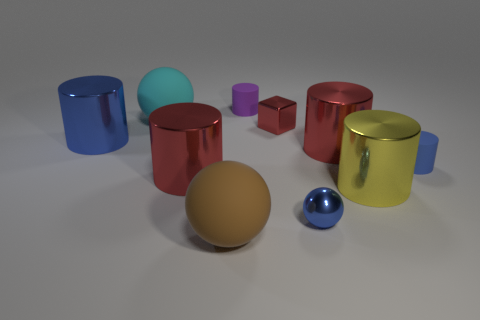What number of blue metal objects are the same shape as the tiny purple matte thing?
Keep it short and to the point. 1. Does the small sphere have the same material as the big red object that is to the right of the purple matte object?
Offer a terse response. Yes. What is the material of the sphere that is the same size as the cyan thing?
Ensure brevity in your answer.  Rubber. Are there any cyan spheres that have the same size as the brown rubber thing?
Make the answer very short. Yes. There is another matte thing that is the same size as the brown object; what is its shape?
Give a very brief answer. Sphere. How many other objects are there of the same color as the metallic ball?
Provide a succinct answer. 2. What shape is the big thing that is in front of the blue rubber cylinder and on the right side of the purple rubber thing?
Your answer should be very brief. Cylinder. There is a tiny rubber object left of the small metal thing in front of the small red metallic block; are there any small purple cylinders in front of it?
Offer a terse response. No. What number of other objects are the same material as the big blue thing?
Offer a terse response. 5. What number of matte cylinders are there?
Make the answer very short. 2. 